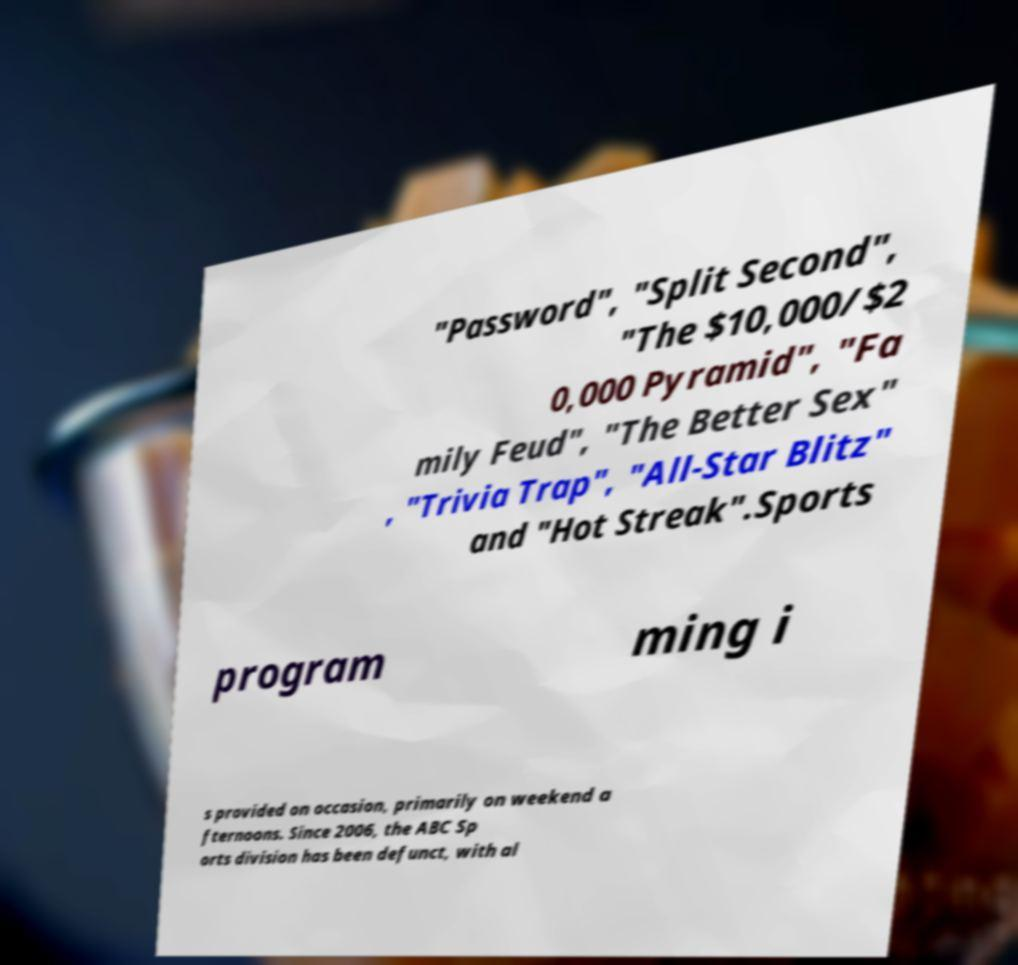Can you read and provide the text displayed in the image?This photo seems to have some interesting text. Can you extract and type it out for me? "Password", "Split Second", "The $10,000/$2 0,000 Pyramid", "Fa mily Feud", "The Better Sex" , "Trivia Trap", "All-Star Blitz" and "Hot Streak".Sports program ming i s provided on occasion, primarily on weekend a fternoons. Since 2006, the ABC Sp orts division has been defunct, with al 